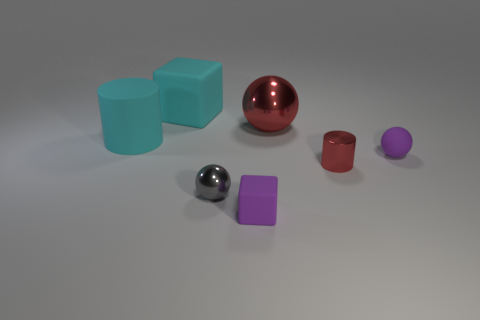Add 1 blue metal spheres. How many objects exist? 8 Subtract all purple rubber balls. How many balls are left? 2 Subtract all purple cubes. How many cubes are left? 1 Subtract 1 spheres. How many spheres are left? 2 Add 5 tiny purple shiny cylinders. How many tiny purple shiny cylinders exist? 5 Subtract 0 yellow cylinders. How many objects are left? 7 Subtract all cylinders. How many objects are left? 5 Subtract all brown spheres. Subtract all green cylinders. How many spheres are left? 3 Subtract all green cubes. How many green cylinders are left? 0 Subtract all rubber spheres. Subtract all large cyan objects. How many objects are left? 4 